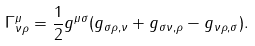Convert formula to latex. <formula><loc_0><loc_0><loc_500><loc_500>\Gamma ^ { \mu } _ { \nu \rho } = \frac { 1 } { 2 } g ^ { \mu \sigma } ( g _ { \sigma \rho , \nu } + g _ { \sigma \nu , \rho } - g _ { \nu \rho , \sigma } ) .</formula> 